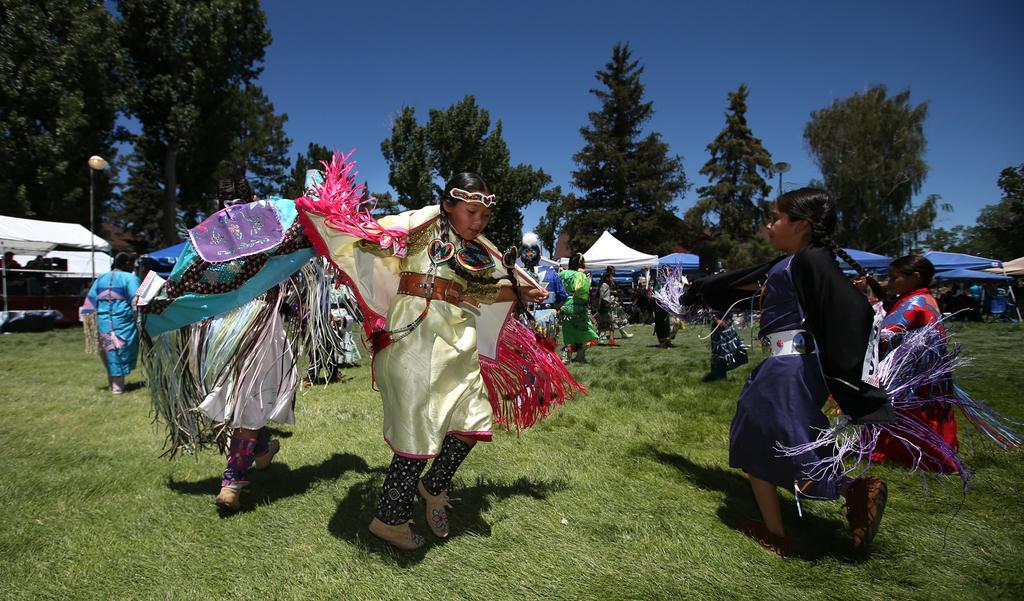How would you summarize this image in a sentence or two? In this image there are people dancing on the grass. In the background of the image there are tents, lights, trees and sky. 